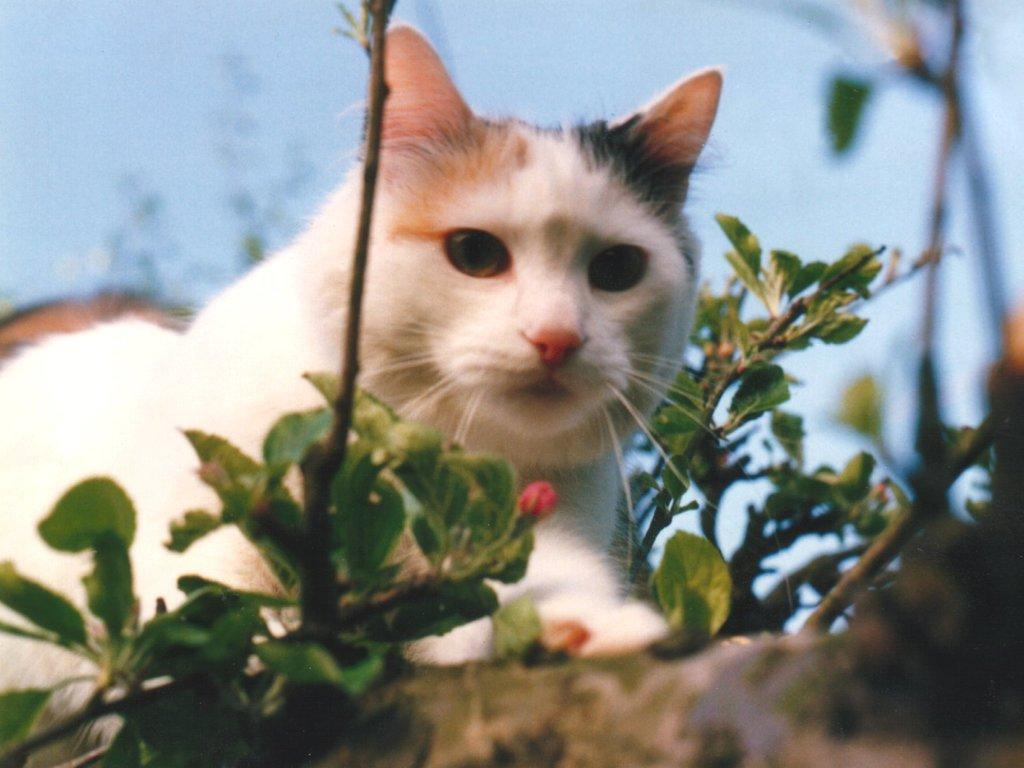What type of animal is in the image? There is a cat in the image. What can be seen on the right side of the image? There is a flower pot and plants on the right side of the image. What color is the sky in the image? The sky is blue in color. How many frogs are sitting on the cat's head in the image? There are no frogs present in the image, and therefore none are sitting on the cat's head. 